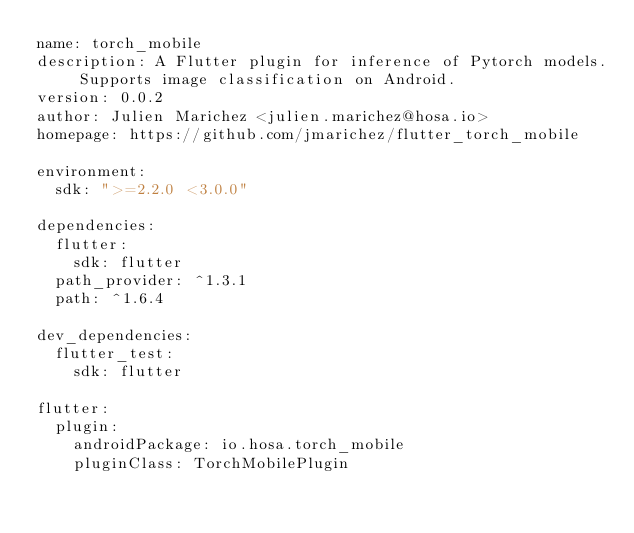<code> <loc_0><loc_0><loc_500><loc_500><_YAML_>name: torch_mobile
description: A Flutter plugin for inference of Pytorch models. Supports image classification on Android.
version: 0.0.2
author: Julien Marichez <julien.marichez@hosa.io>
homepage: https://github.com/jmarichez/flutter_torch_mobile

environment:
  sdk: ">=2.2.0 <3.0.0"

dependencies:
  flutter:
    sdk: flutter
  path_provider: ^1.3.1
  path: ^1.6.4

dev_dependencies:
  flutter_test:
    sdk: flutter

flutter:
  plugin:
    androidPackage: io.hosa.torch_mobile
    pluginClass: TorchMobilePlugin
</code> 